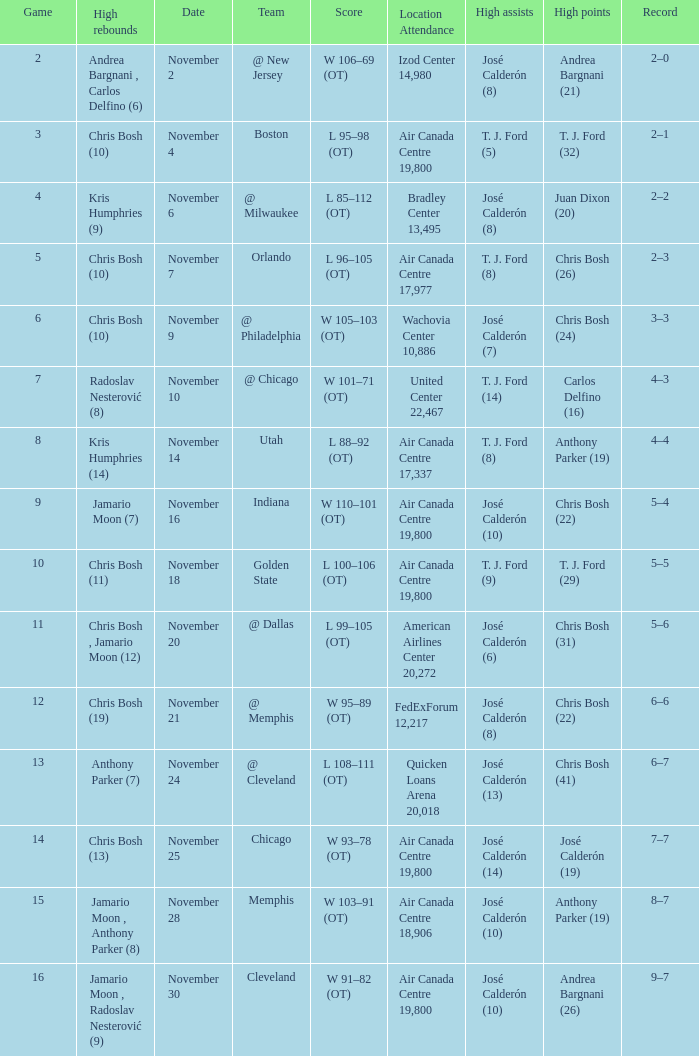What is the score when the team is @ cleveland? L 108–111 (OT). 